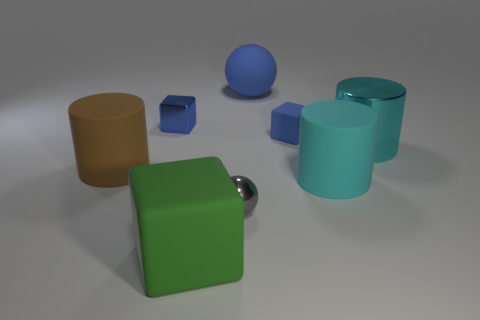Add 2 rubber cylinders. How many objects exist? 10 Subtract all cubes. How many objects are left? 5 Add 2 gray objects. How many gray objects exist? 3 Subtract 0 red balls. How many objects are left? 8 Subtract all tiny cubes. Subtract all large brown cylinders. How many objects are left? 5 Add 8 small gray shiny spheres. How many small gray shiny spheres are left? 9 